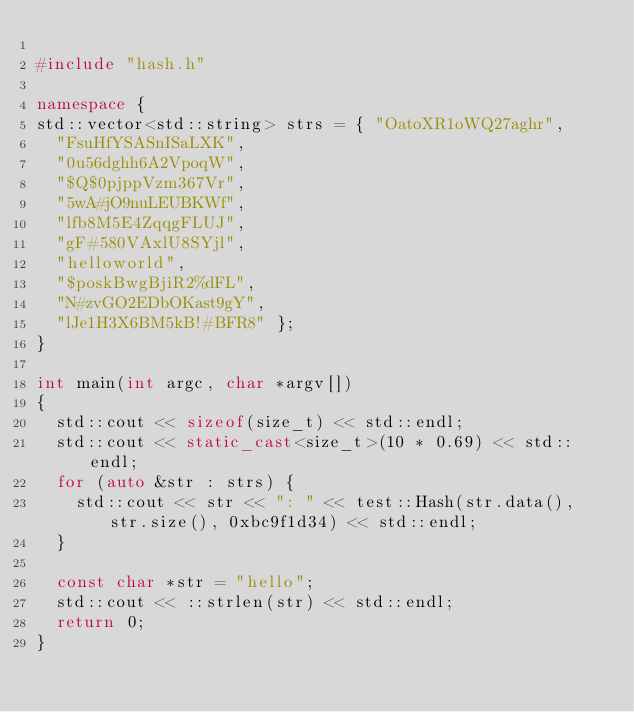<code> <loc_0><loc_0><loc_500><loc_500><_C++_>
#include "hash.h"

namespace {
std::vector<std::string> strs = { "OatoXR1oWQ27aghr",
  "FsuHfYSASnISaLXK",
  "0u56dghh6A2VpoqW",
  "$Q$0pjppVzm367Vr",
  "5wA#jO9nuLEUBKWf",
  "lfb8M5E4ZqqgFLUJ",
  "gF#580VAxlU8SYjl",
  "helloworld",
  "$poskBwgBjiR2%dFL",
  "N#zvGO2EDbOKast9gY",
  "lJe1H3X6BM5kB!#BFR8" };
}

int main(int argc, char *argv[])
{
  std::cout << sizeof(size_t) << std::endl;
  std::cout << static_cast<size_t>(10 * 0.69) << std::endl;
  for (auto &str : strs) {
    std::cout << str << ": " << test::Hash(str.data(), str.size(), 0xbc9f1d34) << std::endl;
  }

  const char *str = "hello";
  std::cout << ::strlen(str) << std::endl;
  return 0;
}
</code> 